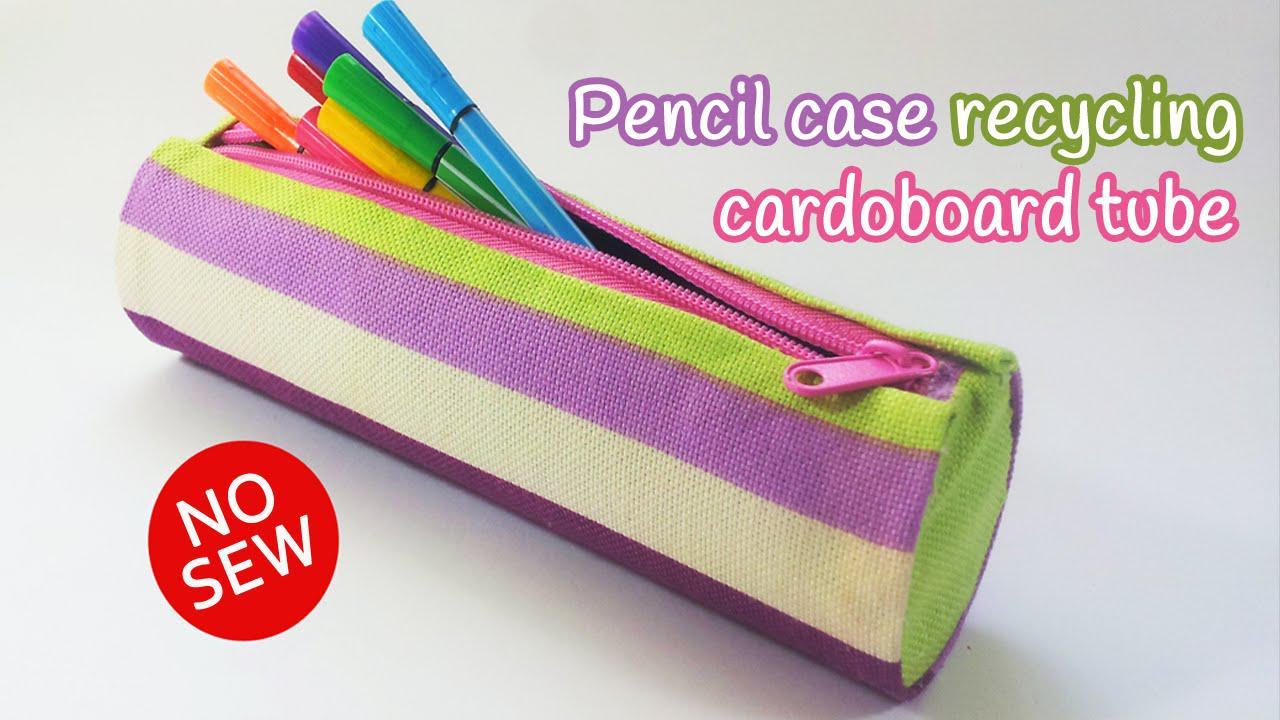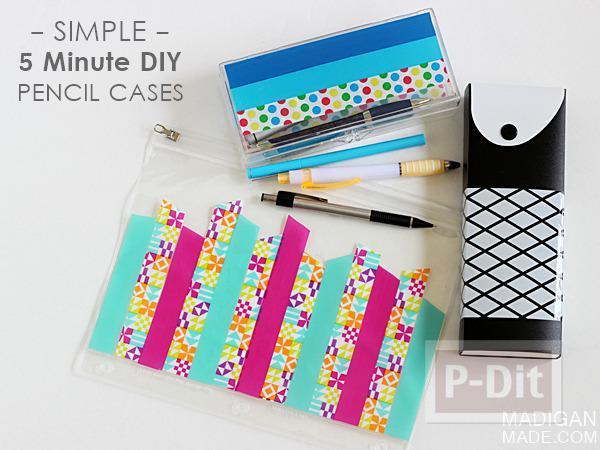The first image is the image on the left, the second image is the image on the right. Assess this claim about the two images: "The left image shows just one cyindrical pencil case.". Correct or not? Answer yes or no. Yes. The first image is the image on the left, the second image is the image on the right. Considering the images on both sides, is "One image features a single pastel-colored plastic-look case with a side part that can extend outward." valid? Answer yes or no. No. The first image is the image on the left, the second image is the image on the right. Analyze the images presented: Is the assertion "There is a predominantly pink pencel case on top of a white table in one of the images." valid? Answer yes or no. No. 